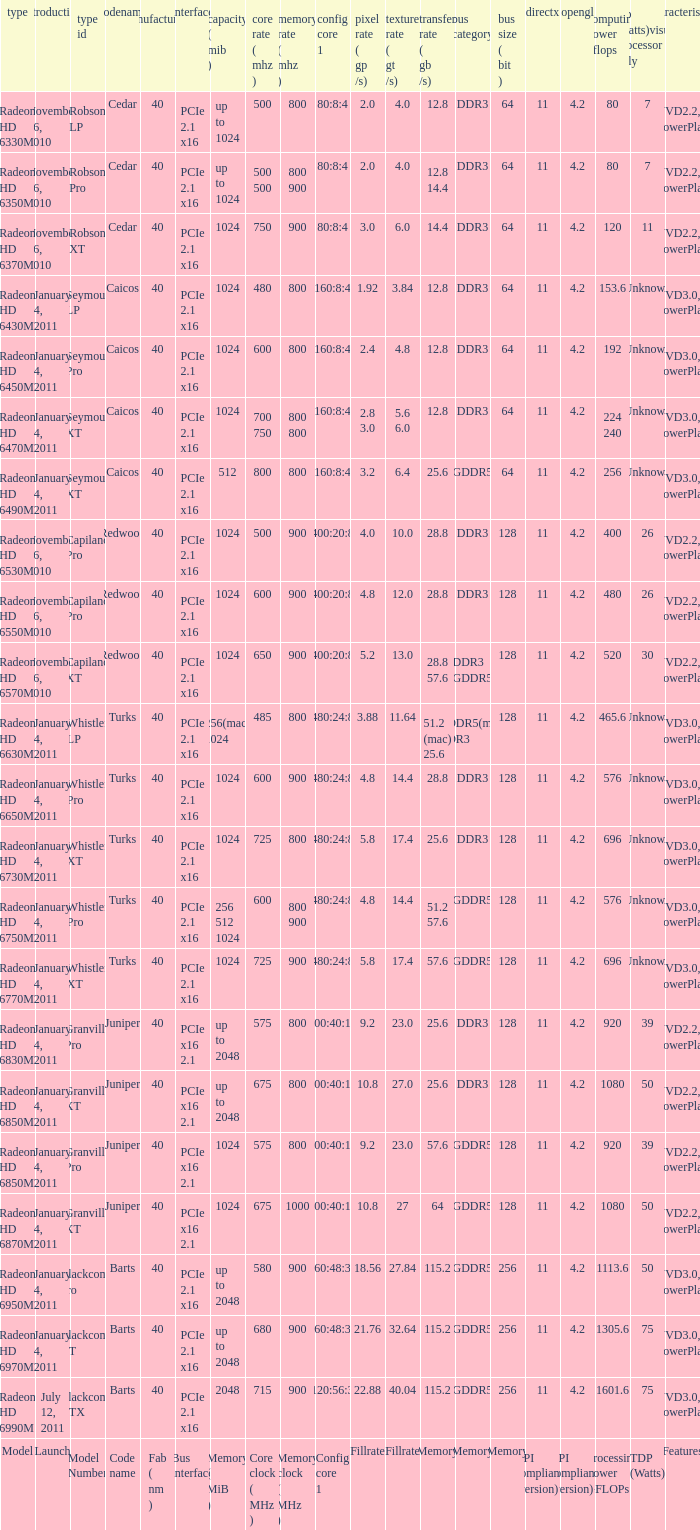How many values for bus width have a bandwidth of 25.6 and model number of Granville Pro? 1.0. 